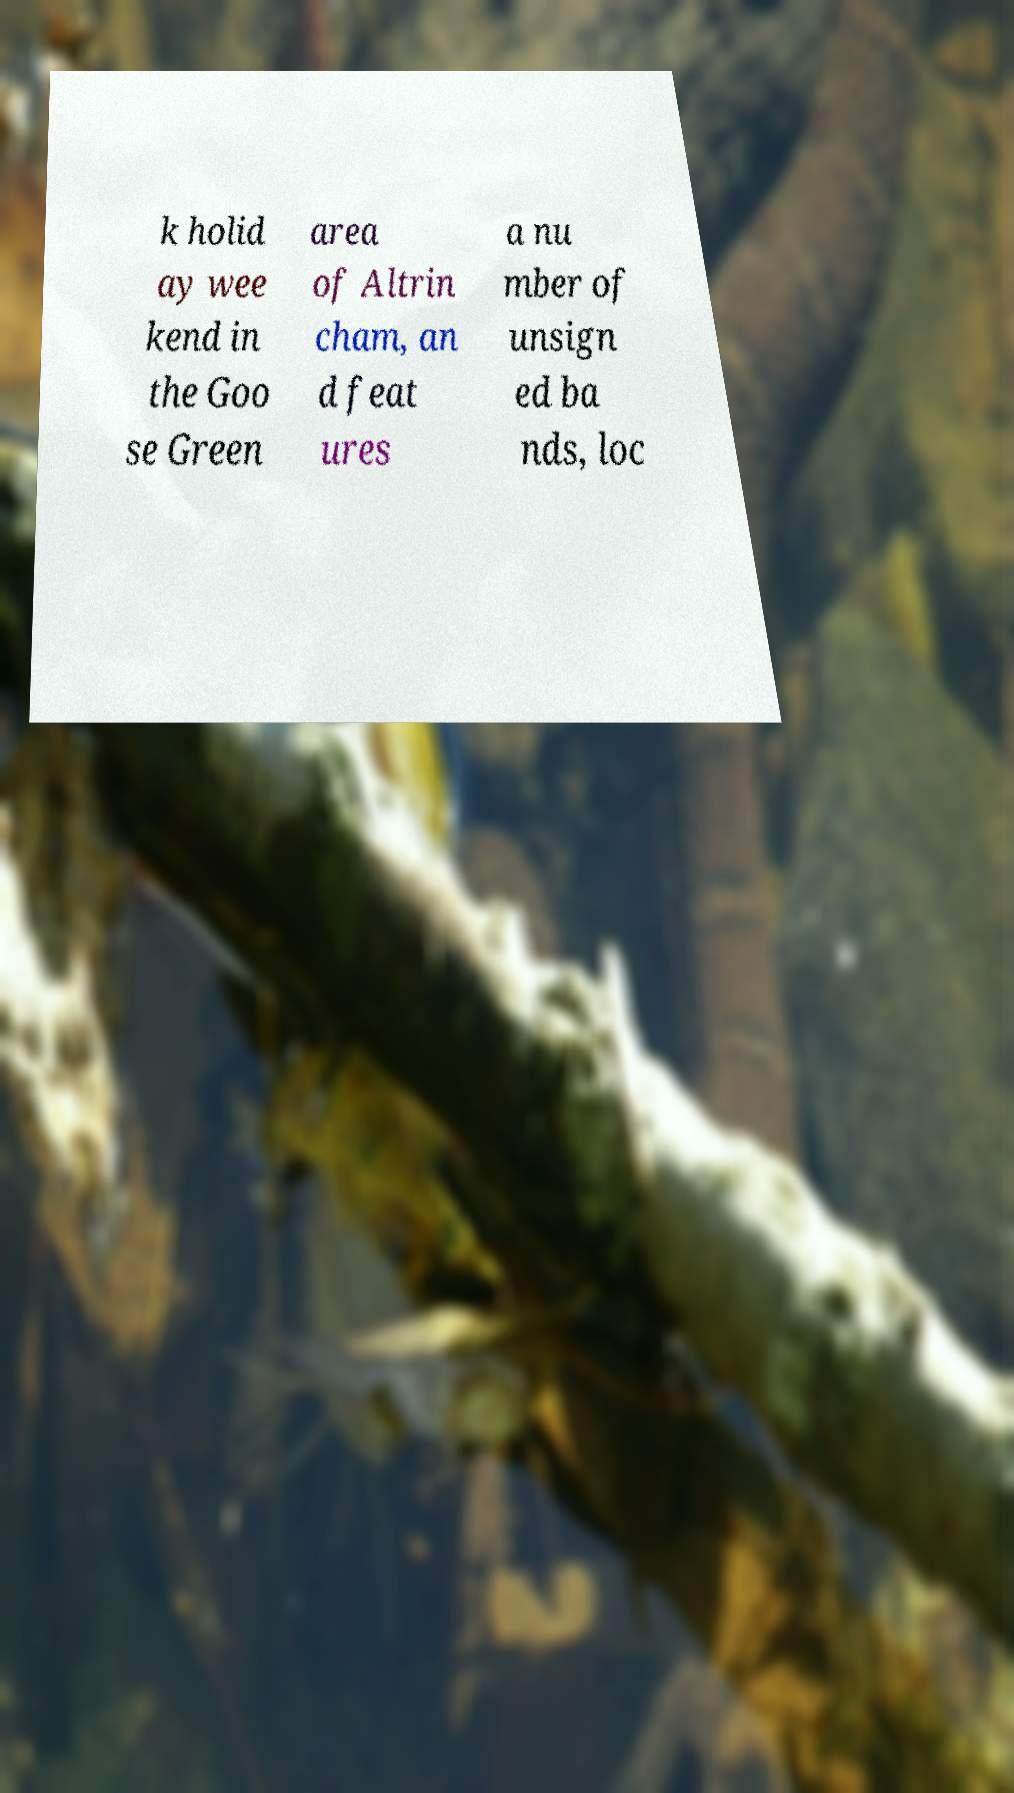For documentation purposes, I need the text within this image transcribed. Could you provide that? k holid ay wee kend in the Goo se Green area of Altrin cham, an d feat ures a nu mber of unsign ed ba nds, loc 